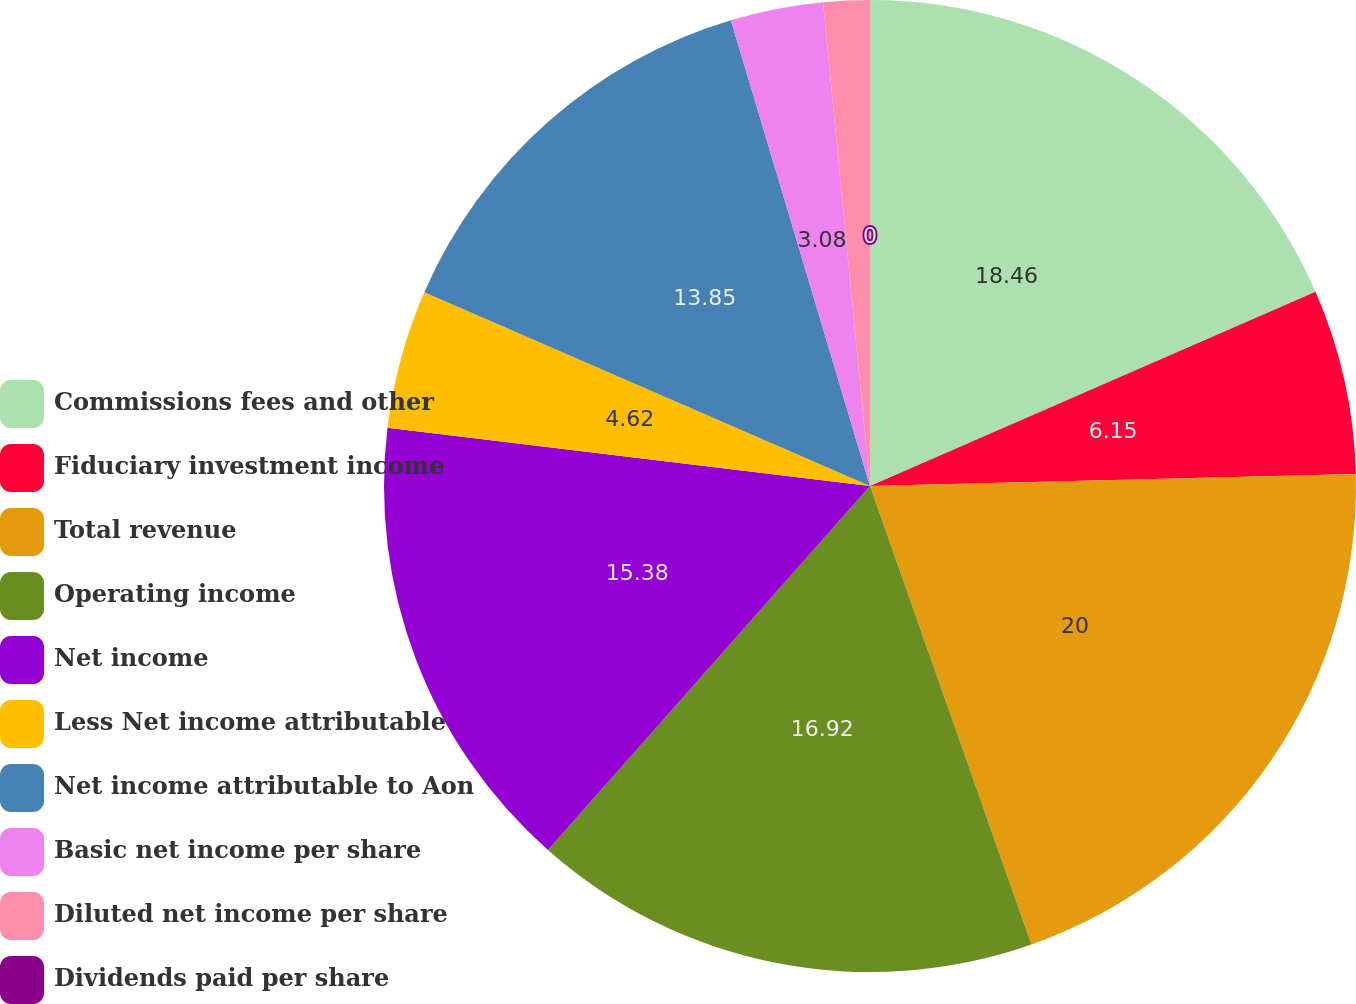Convert chart. <chart><loc_0><loc_0><loc_500><loc_500><pie_chart><fcel>Commissions fees and other<fcel>Fiduciary investment income<fcel>Total revenue<fcel>Operating income<fcel>Net income<fcel>Less Net income attributable<fcel>Net income attributable to Aon<fcel>Basic net income per share<fcel>Diluted net income per share<fcel>Dividends paid per share<nl><fcel>18.46%<fcel>6.15%<fcel>20.0%<fcel>16.92%<fcel>15.38%<fcel>4.62%<fcel>13.85%<fcel>3.08%<fcel>1.54%<fcel>0.0%<nl></chart> 